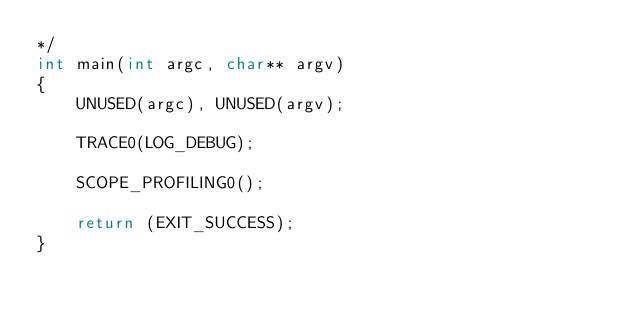Convert code to text. <code><loc_0><loc_0><loc_500><loc_500><_C++_>*/
int main(int argc, char** argv)
{
    UNUSED(argc), UNUSED(argv);

    TRACE0(LOG_DEBUG);

    SCOPE_PROFILING0();

    return (EXIT_SUCCESS);
}

</code> 